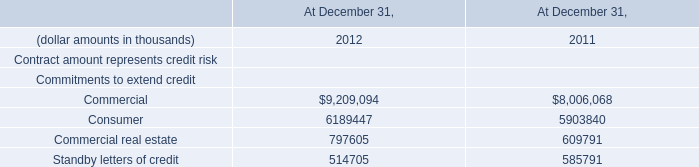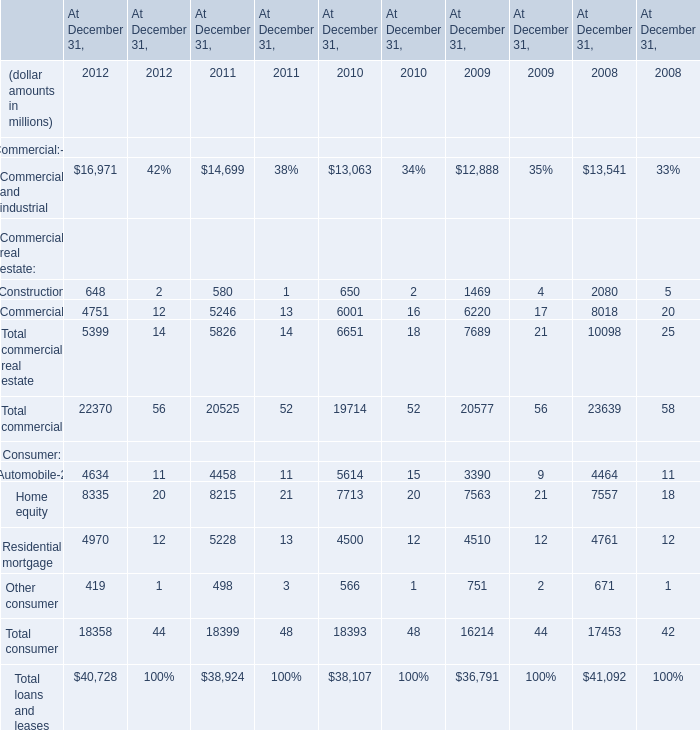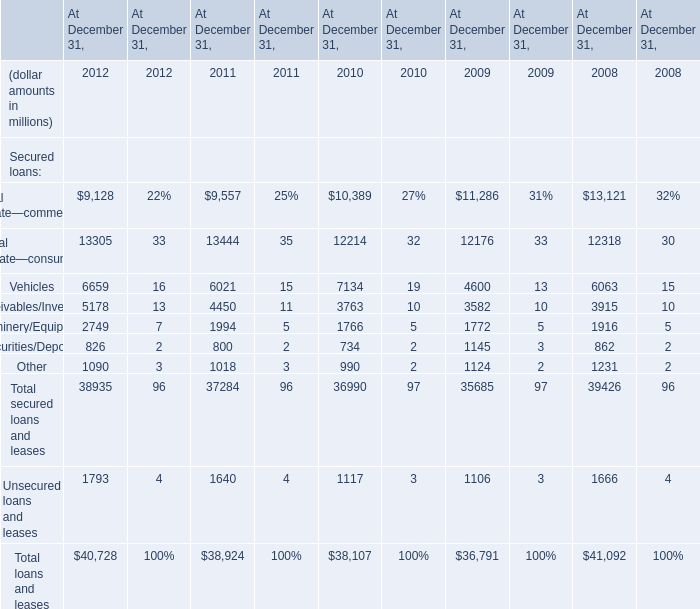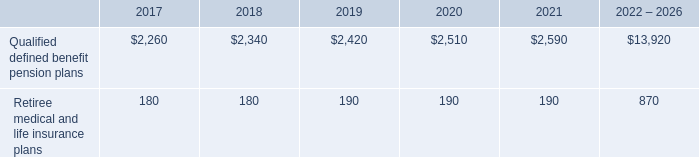What is the ratio of all Secured loans that are in the range of 0 and 2000 in 2012? 
Computations: (((826 + 1090) + 1793) / 40728)
Answer: 0.09107. 